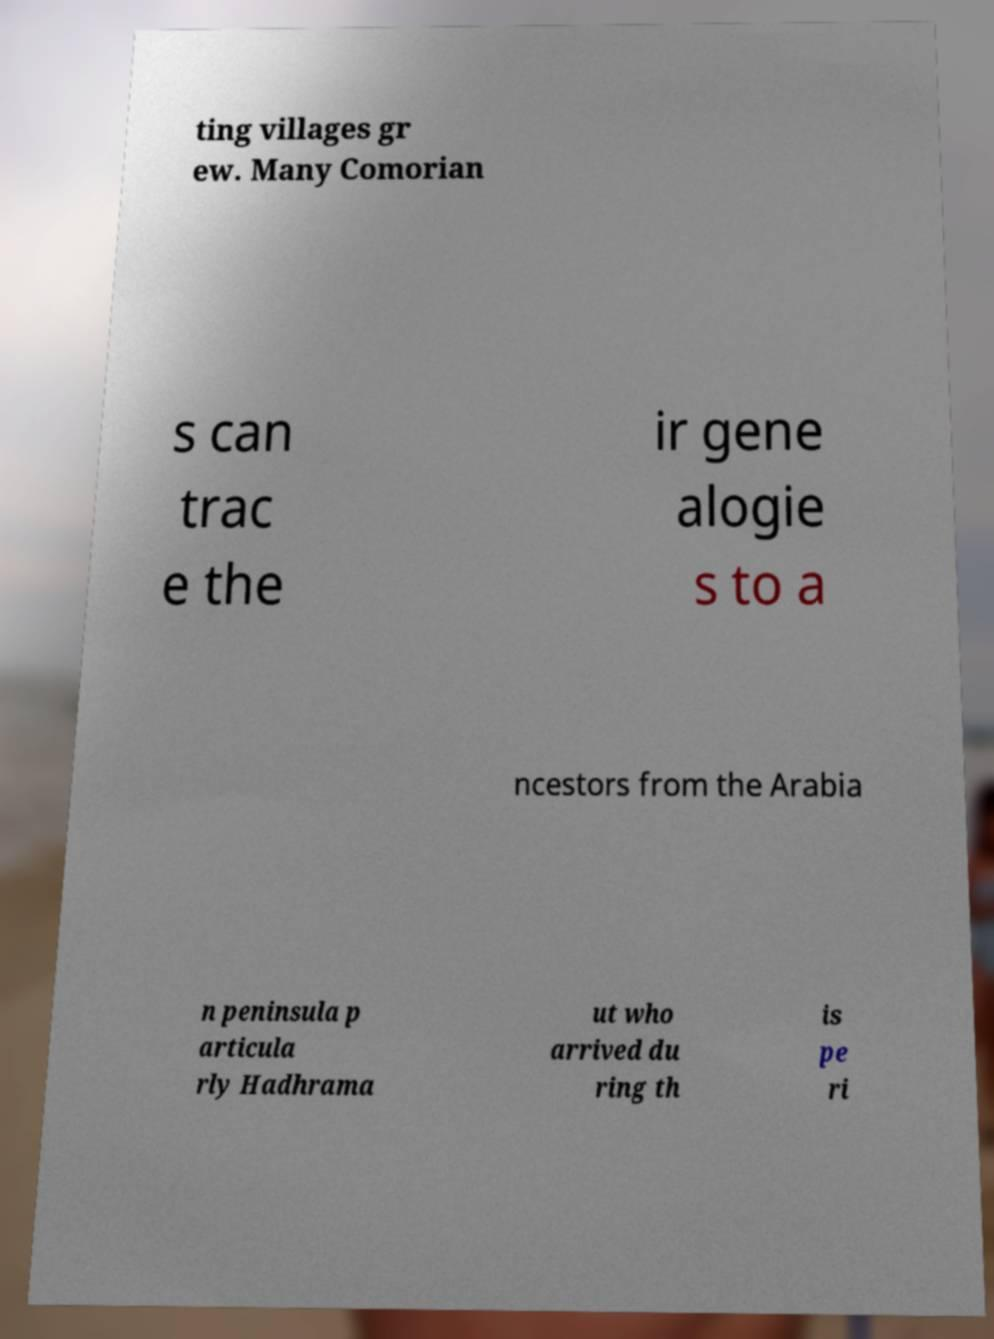I need the written content from this picture converted into text. Can you do that? ting villages gr ew. Many Comorian s can trac e the ir gene alogie s to a ncestors from the Arabia n peninsula p articula rly Hadhrama ut who arrived du ring th is pe ri 